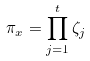Convert formula to latex. <formula><loc_0><loc_0><loc_500><loc_500>\pi _ { x } = \prod _ { j = 1 } ^ { t } \zeta _ { j }</formula> 